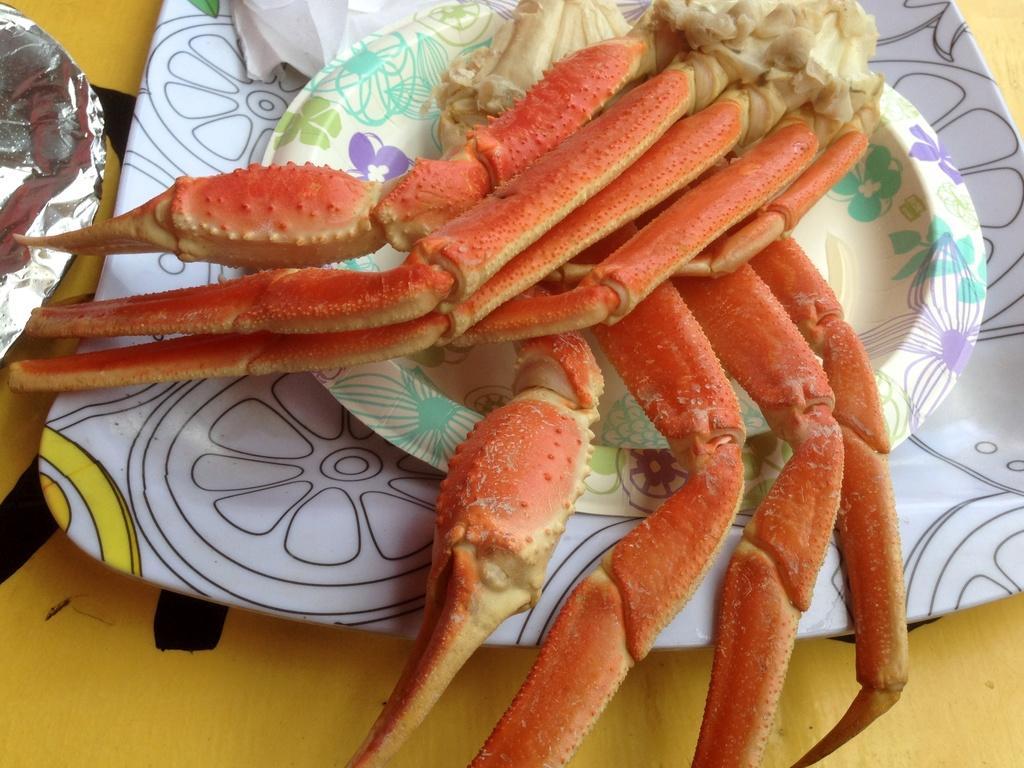Describe this image in one or two sentences. In this image we can see a plate with some food, there are some other plates on the table, also we can see a tissue. 